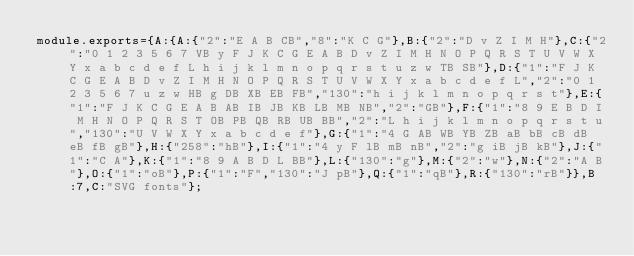<code> <loc_0><loc_0><loc_500><loc_500><_JavaScript_>module.exports={A:{A:{"2":"E A B CB","8":"K C G"},B:{"2":"D v Z I M H"},C:{"2":"0 1 2 3 5 6 7 VB y F J K C G E A B D v Z I M H N O P Q R S T U V W X Y x a b c d e f L h i j k l m n o p q r s t u z w TB SB"},D:{"1":"F J K C G E A B D v Z I M H N O P Q R S T U V W X Y x a b c d e f L","2":"0 1 2 3 5 6 7 u z w HB g DB XB EB FB","130":"h i j k l m n o p q r s t"},E:{"1":"F J K C G E A B AB IB JB KB LB MB NB","2":"GB"},F:{"1":"8 9 E B D I M H N O P Q R S T OB PB QB RB UB BB","2":"L h i j k l m n o p q r s t u","130":"U V W X Y x a b c d e f"},G:{"1":"4 G AB WB YB ZB aB bB cB dB eB fB gB"},H:{"258":"hB"},I:{"1":"4 y F lB mB nB","2":"g iB jB kB"},J:{"1":"C A"},K:{"1":"8 9 A B D L BB"},L:{"130":"g"},M:{"2":"w"},N:{"2":"A B"},O:{"1":"oB"},P:{"1":"F","130":"J pB"},Q:{"1":"qB"},R:{"130":"rB"}},B:7,C:"SVG fonts"};
</code> 